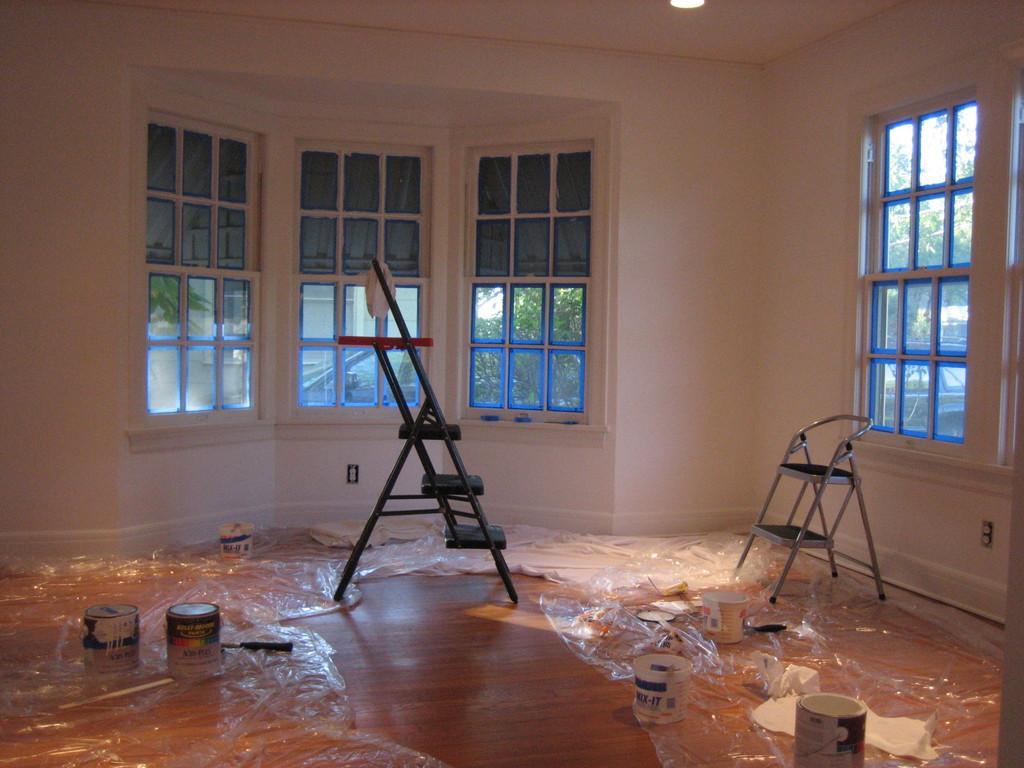Could you give a brief overview of what you see in this image? In this picture we can see ladder, chair, cover and objects on the floor. We can see wall and glass windows, through glass windows we can see leaves. At the top of the image we can see light. 